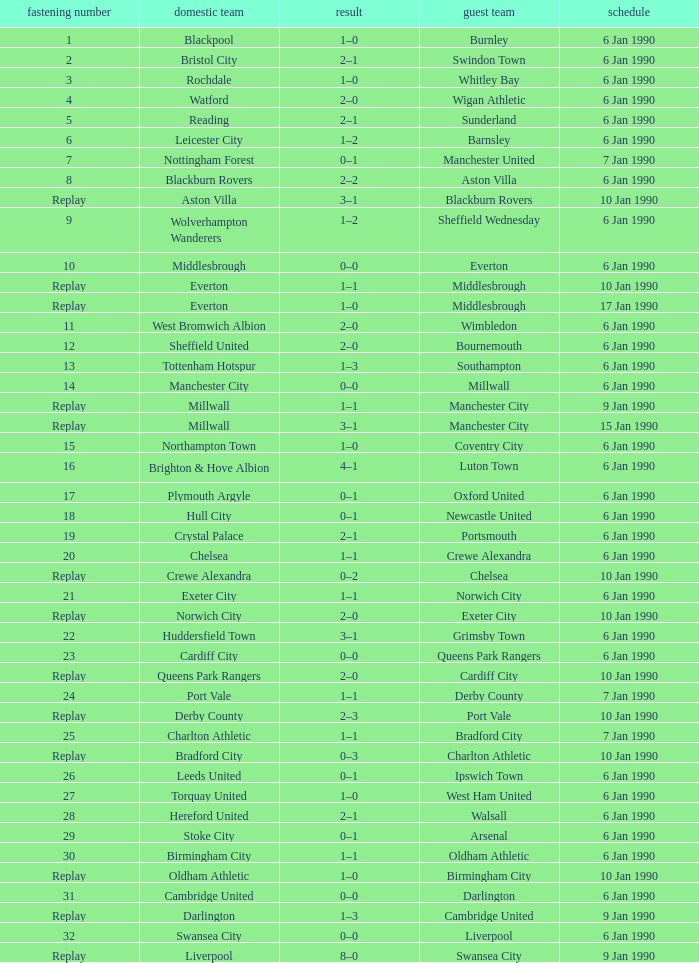What is the tie no of the game where exeter city was the home team? 21.0. 